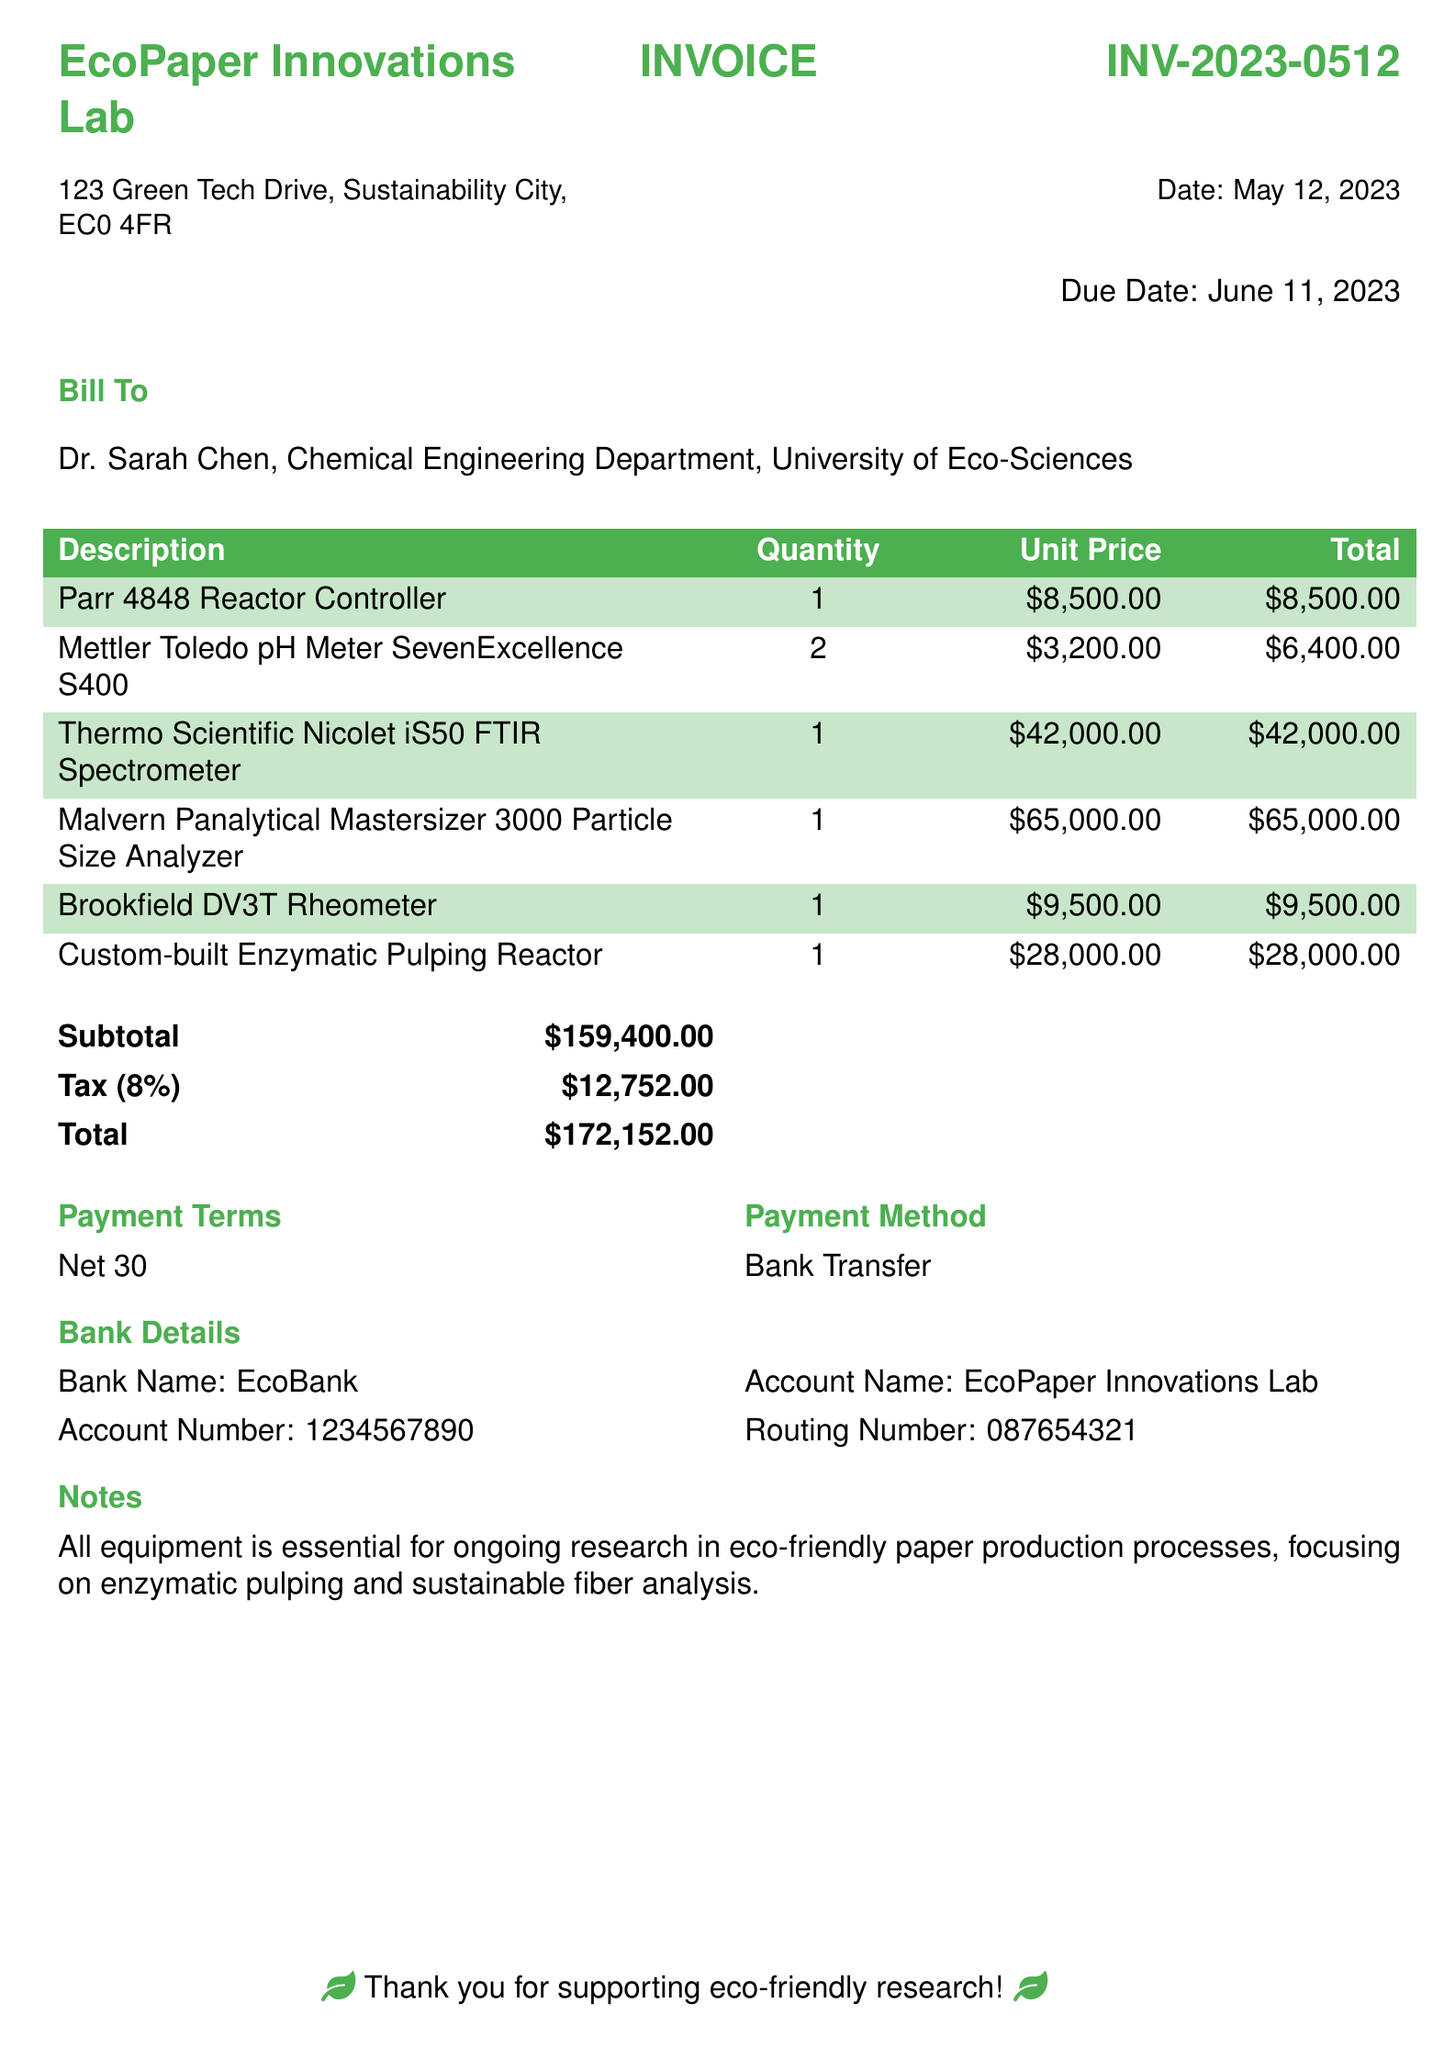What is the invoice number? The invoice number is clearly listed in the document as INV-2023-0512.
Answer: INV-2023-0512 What is the total amount due? The total amount due is specified at the bottom of the invoice as $172,152.00.
Answer: $172,152.00 Who is the bill addressed to? The bill is addressed to Dr. Sarah Chen, as indicated in the "Bill To" section.
Answer: Dr. Sarah Chen What equipment was customized for the research? The document lists a custom-built Enzymatic Pulping Reactor as the specialized equipment.
Answer: Custom-built Enzymatic Pulping Reactor What is the tax rate applied to the invoice? The tax rate is provided as 8%, which is used to calculate the tax amount in the invoice.
Answer: 8% What is the payment term specified in the document? The payment term outlined in the document is "Net 30."
Answer: Net 30 How many Mettler Toledo pH Meters were ordered? The document indicates a quantity of 2 for the Mettler Toledo pH Meter.
Answer: 2 What is the total cost for the Thermo Scientific Nicolet iS50 FTIR Spectrometer? The cost for this item is shown as $42,000.00 in the total column.
Answer: $42,000.00 What bank is mentioned for the payment? The document states EcoBank as the bank for transferring payments.
Answer: EcoBank 